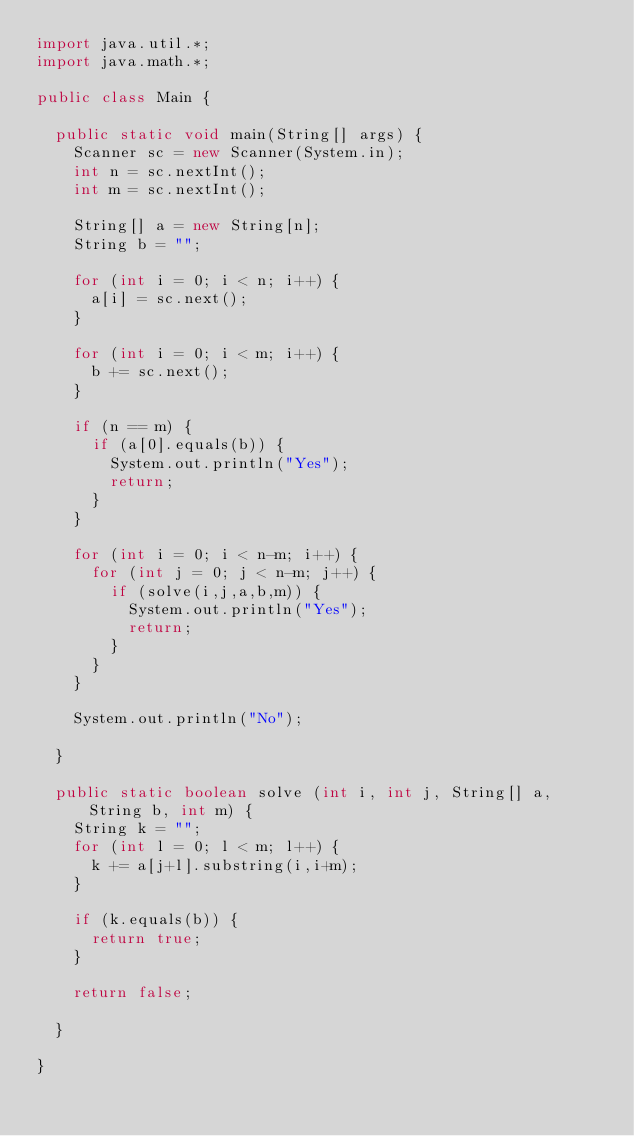Convert code to text. <code><loc_0><loc_0><loc_500><loc_500><_Java_>import java.util.*;
import java.math.*;

public class Main {

  public static void main(String[] args) {
    Scanner sc = new Scanner(System.in);
    int n = sc.nextInt();
    int m = sc.nextInt();

    String[] a = new String[n];
    String b = "";

    for (int i = 0; i < n; i++) {
      a[i] = sc.next();
    }

    for (int i = 0; i < m; i++) {
      b += sc.next();
    }

    if (n == m) {
      if (a[0].equals(b)) {
        System.out.println("Yes");
        return;
      }
    }

    for (int i = 0; i < n-m; i++) {
      for (int j = 0; j < n-m; j++) {
        if (solve(i,j,a,b,m)) {
          System.out.println("Yes");
          return;
        }
      }
    }

    System.out.println("No");

  }

  public static boolean solve (int i, int j, String[] a, String b, int m) {
    String k = "";
    for (int l = 0; l < m; l++) {
      k += a[j+l].substring(i,i+m);
    }

    if (k.equals(b)) {
      return true;
    }

    return false;

  }

}
</code> 